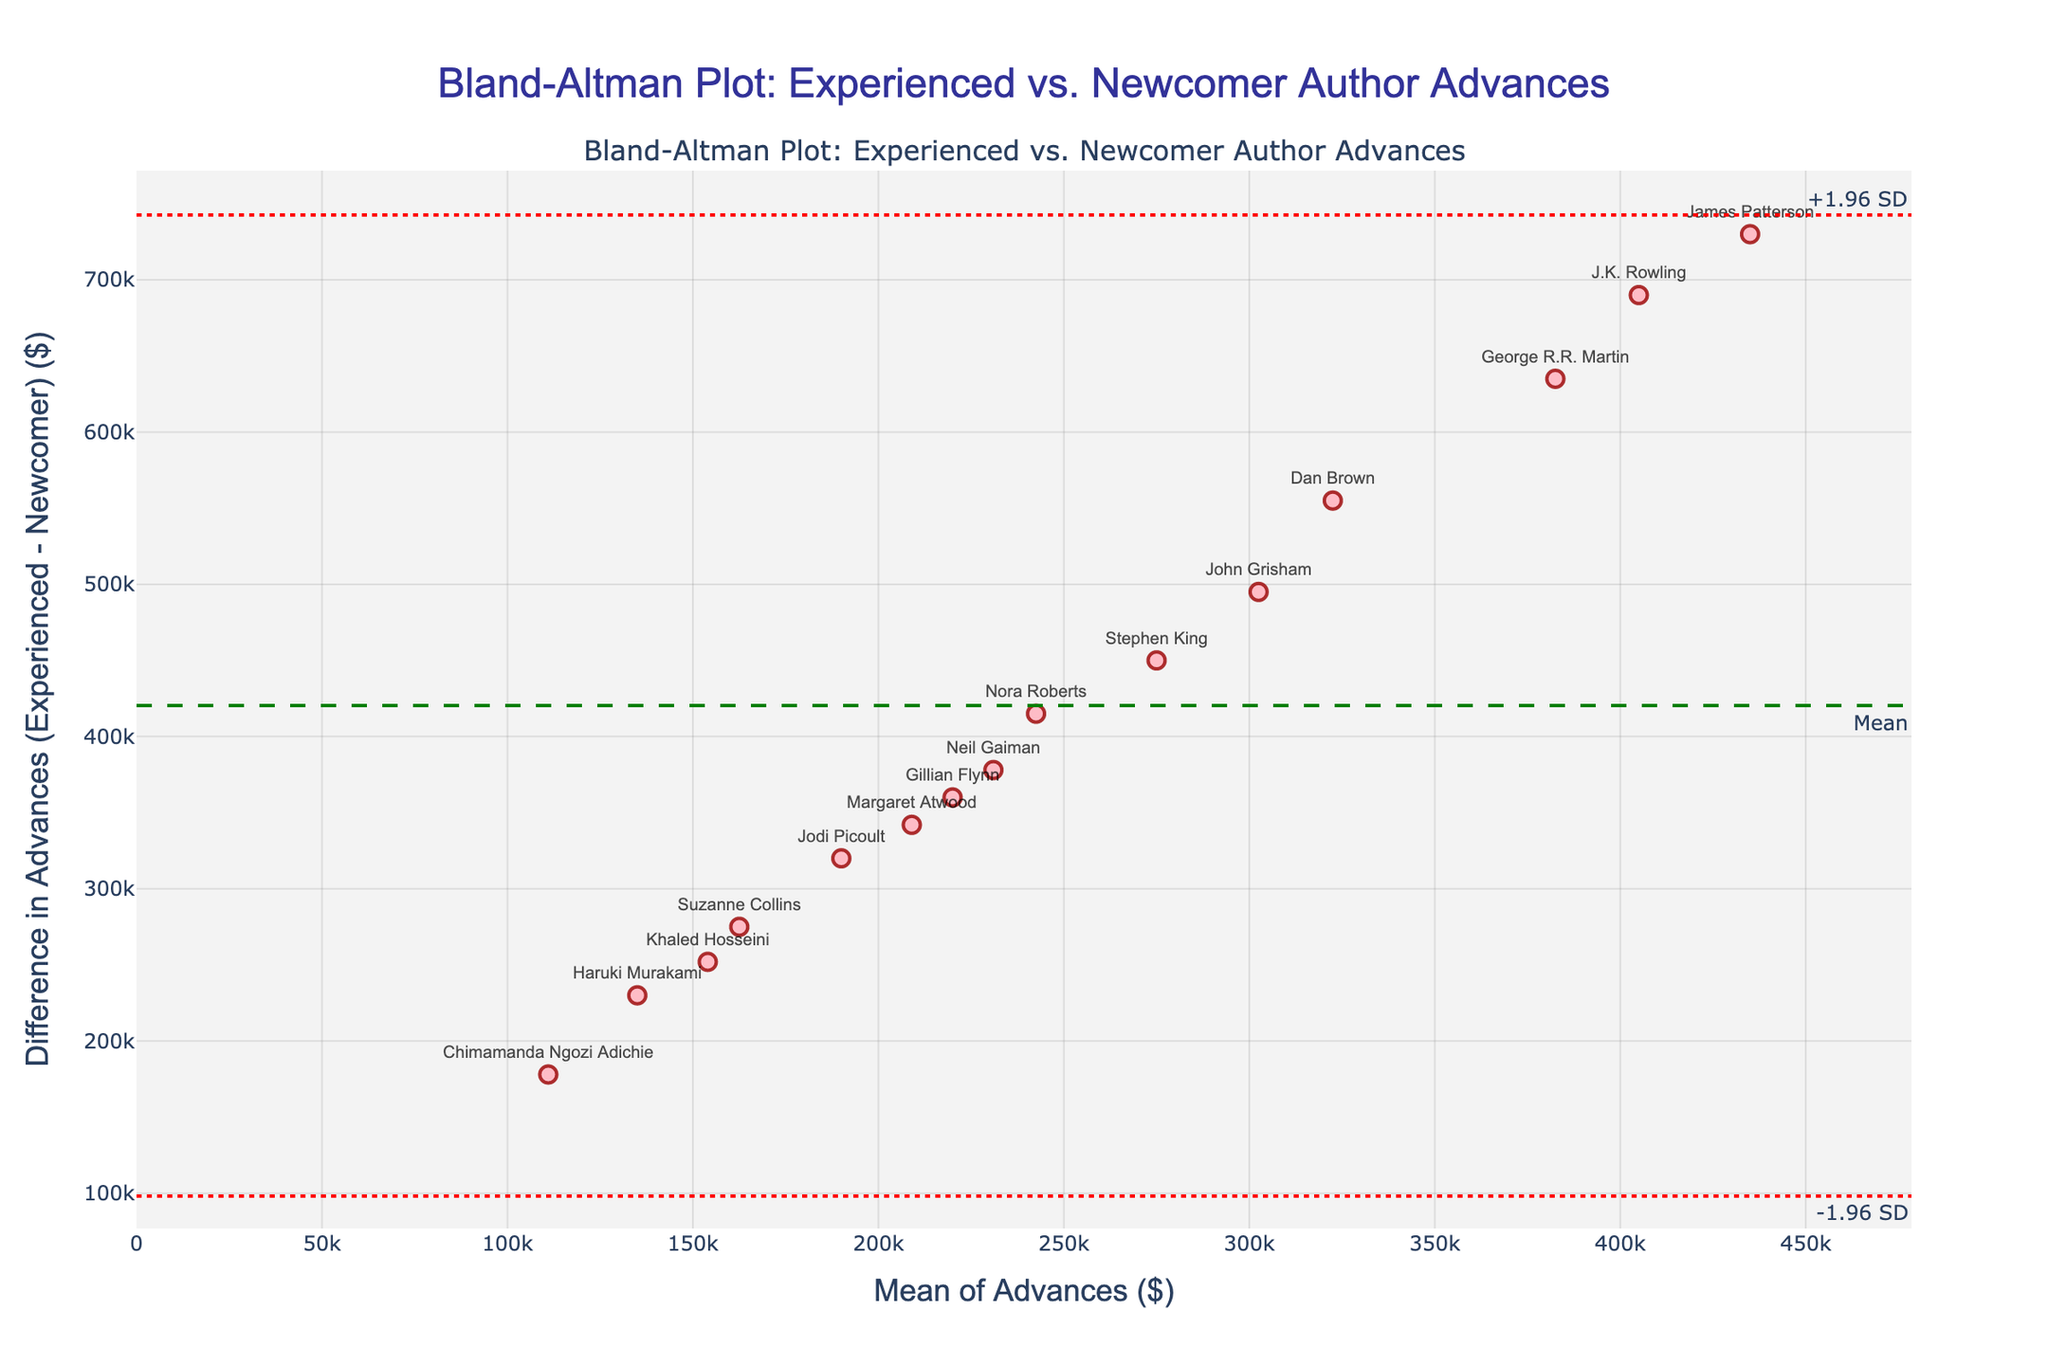What's the title of the plot? The title is located at the top-center of the plot in a large, bold font and provides a summary of the content.
Answer: Bland-Altman Plot: Experienced vs. Newcomer Author Advances What do the x-axis and y-axis represent? The x-axis title is "Mean of Advances ($)" and the y-axis title is "Difference in Advances (Experienced - Newcomer) ($)".
Answer: Mean of Advances ($) and Difference in Advances (Experienced - Newcomer) ($) Which author received the largest advance as an experienced writer? To find this, look for the highest difference value on the y-axis, then identify the corresponding author from the plot annotations.
Answer: James Patterson What is the range of the x-axis in the plot? The x-axis range can be estimated by examining the labels provided on either end of the axis.
Answer: 0 to approximately 440,000 What does the green dashed horizontal line represent? The green dashed line has an annotation labeled "Mean", indicating it represents the mean difference between experienced and newcomer advances.
Answer: Mean difference What are the upper and lower limits of agreement (the red dotted lines) on the plot? The red dotted lines represent the limits of agreement with annotations "+1.96 SD" (upper limit) and "-1.96 SD" (lower limit).
Answer: +398,869 and -249,315 Which two authors have their advances most closely aligned, indicating the smallest difference? Look at the points with values closest to zero on the y-axis and identify the corresponding authors from the annotations.
Answer: Margaret Atwood and Neil Gaiman How many authors received an advance of $300,000 or more as experienced writers? Identify the points where the mean value on the x-axis is greater than or equal to $300,000. Count these points.
Answer: 8 Is there any author whose difference in advances is below the lower limit of agreement? Examine the plot for any points that lie below the lower red dotted line and read the corresponding annotations.
Answer: Khaled Hosseini What does it indicate if an author's difference in advances lies outside the limits of agreement? Points outside the limits of agreement indicate that the difference in advances for these authors is unusual and significantly deviates from the mean difference.
Answer: Unusual deviations 